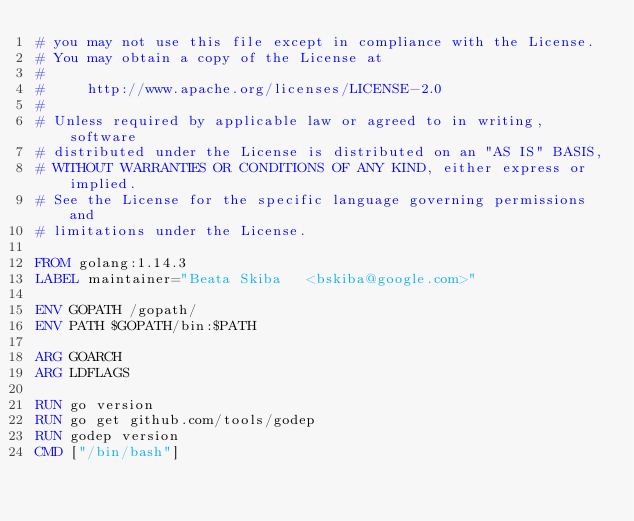<code> <loc_0><loc_0><loc_500><loc_500><_Dockerfile_># you may not use this file except in compliance with the License.
# You may obtain a copy of the License at
#
#     http://www.apache.org/licenses/LICENSE-2.0
#
# Unless required by applicable law or agreed to in writing, software
# distributed under the License is distributed on an "AS IS" BASIS,
# WITHOUT WARRANTIES OR CONDITIONS OF ANY KIND, either express or implied.
# See the License for the specific language governing permissions and
# limitations under the License.

FROM golang:1.14.3
LABEL maintainer="Beata Skiba	<bskiba@google.com>"

ENV GOPATH /gopath/
ENV PATH $GOPATH/bin:$PATH

ARG GOARCH
ARG LDFLAGS

RUN go version
RUN go get github.com/tools/godep
RUN godep version
CMD ["/bin/bash"]
</code> 